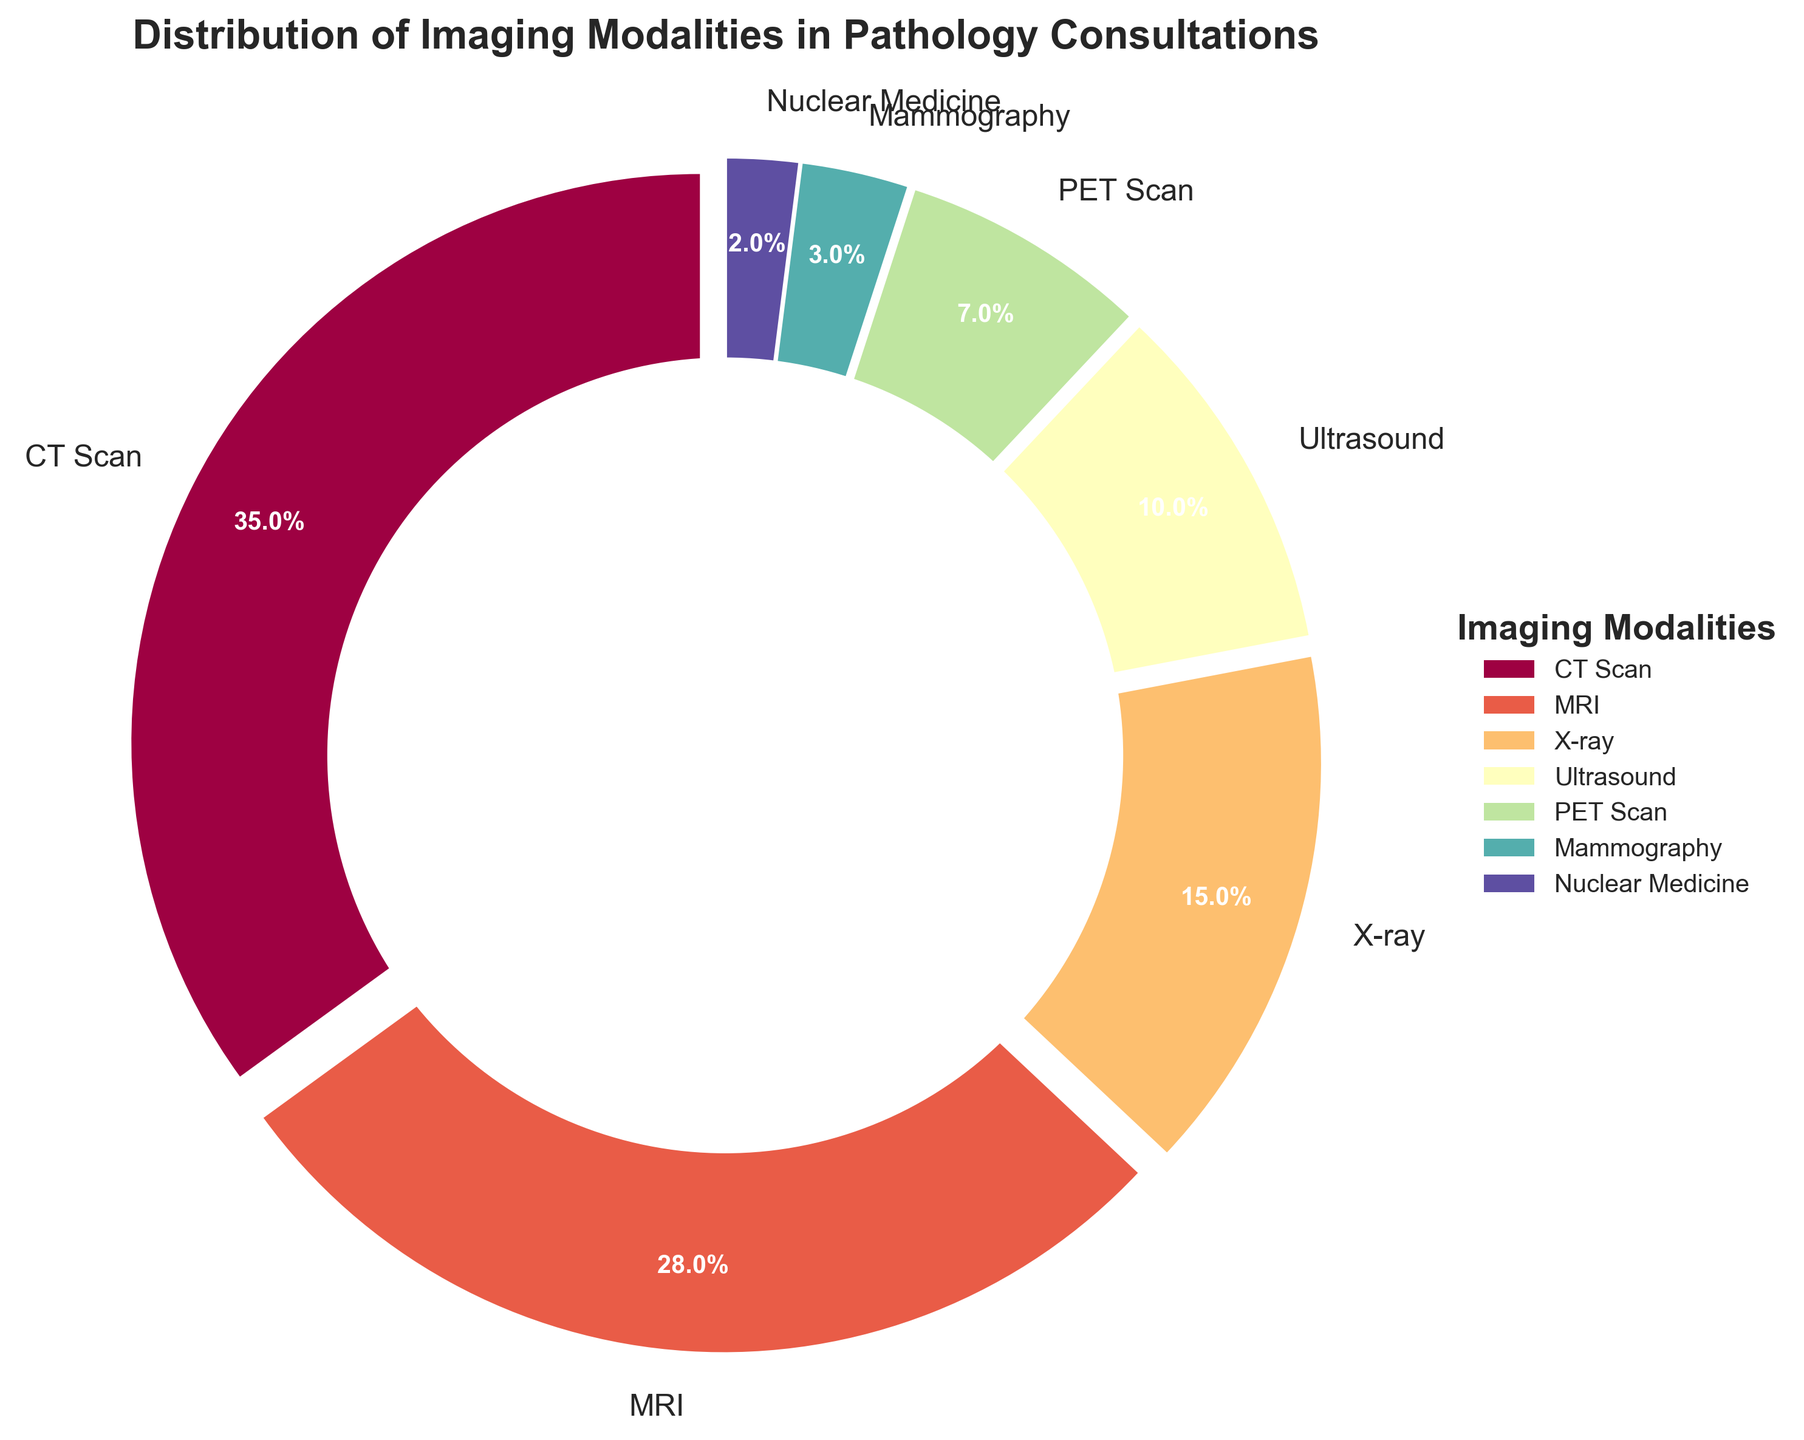What percentage of the total imaging modalities does CT scan represent? The pie chart shows that CT scan represents 35% of the total imaging modalities.
Answer: 35% Which imaging modality is used the least in pathology consultations? The pie chart indicates that Nuclear Medicine has the smallest percentage, at 2%.
Answer: Nuclear Medicine What is the total percentage of consultations that use MRI and Ultrasound together? Adding the percentages for MRI (28%) and Ultrasound (10%) gives us 28 + 10 = 38%.
Answer: 38% Are X-ray consultations more common than Ultrasound consultations? The pie chart shows that X-ray consultations account for 15%, whereas Ultrasound consultations account for 10%. Therefore, X-ray consultations are indeed more common.
Answer: Yes Which imaging modality is represented in green? According to the pie chart's color scheme, MRI is marked in green.
Answer: MRI Is the percentage of X-ray consultations greater or smaller than that of PET Scan consultations? The pie chart indicates that X-ray consultations account for 15% while PET Scan consultations account for 7%, so X-ray consultations are greater.
Answer: Greater What is the combined percentage of MRI, PET Scan, and Nuclear Medicine consultations? Adding the percentages for MRI (28%), PET Scan (7%), and Nuclear Medicine (2%) results in 28 + 7 + 2 = 37%.
Answer: 37% Which imaging modalities together make up more than half (over 50%) of the consultations? The pie chart shows CT Scan (35%) and MRI (28%) together make up a total of 35 + 28 = 63%, which is more than 50%.
Answer: CT Scan and MRI How do the percentages of CT scan and MRI consultations compare? The pie chart shows that CT scan consultations are 35%, and MRI consultations are 28%. So, CT scan consultations are more frequent by 7%.
Answer: CT Scan is 7% more frequent What is the difference in percentage between Mammography and Nuclear Medicine consultations? The pie chart shows Mammography at 3% and Nuclear Medicine at 2%. The difference is 3 - 2 = 1%.
Answer: 1% 